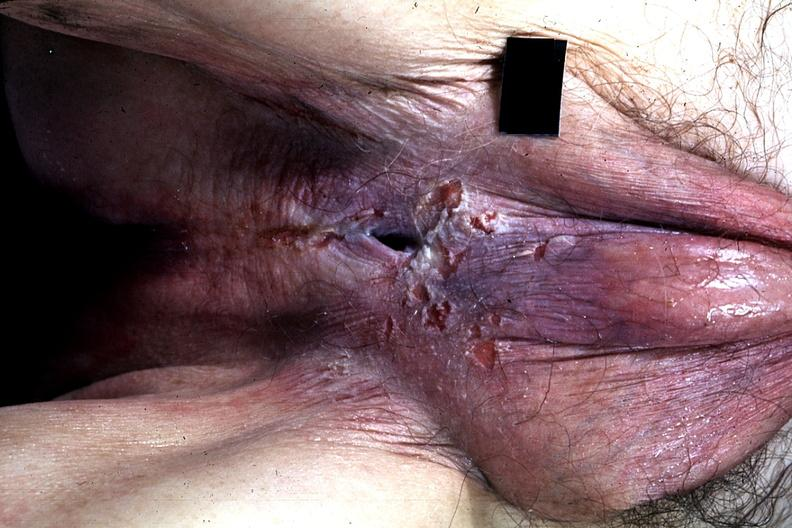s penis present?
Answer the question using a single word or phrase. Yes 